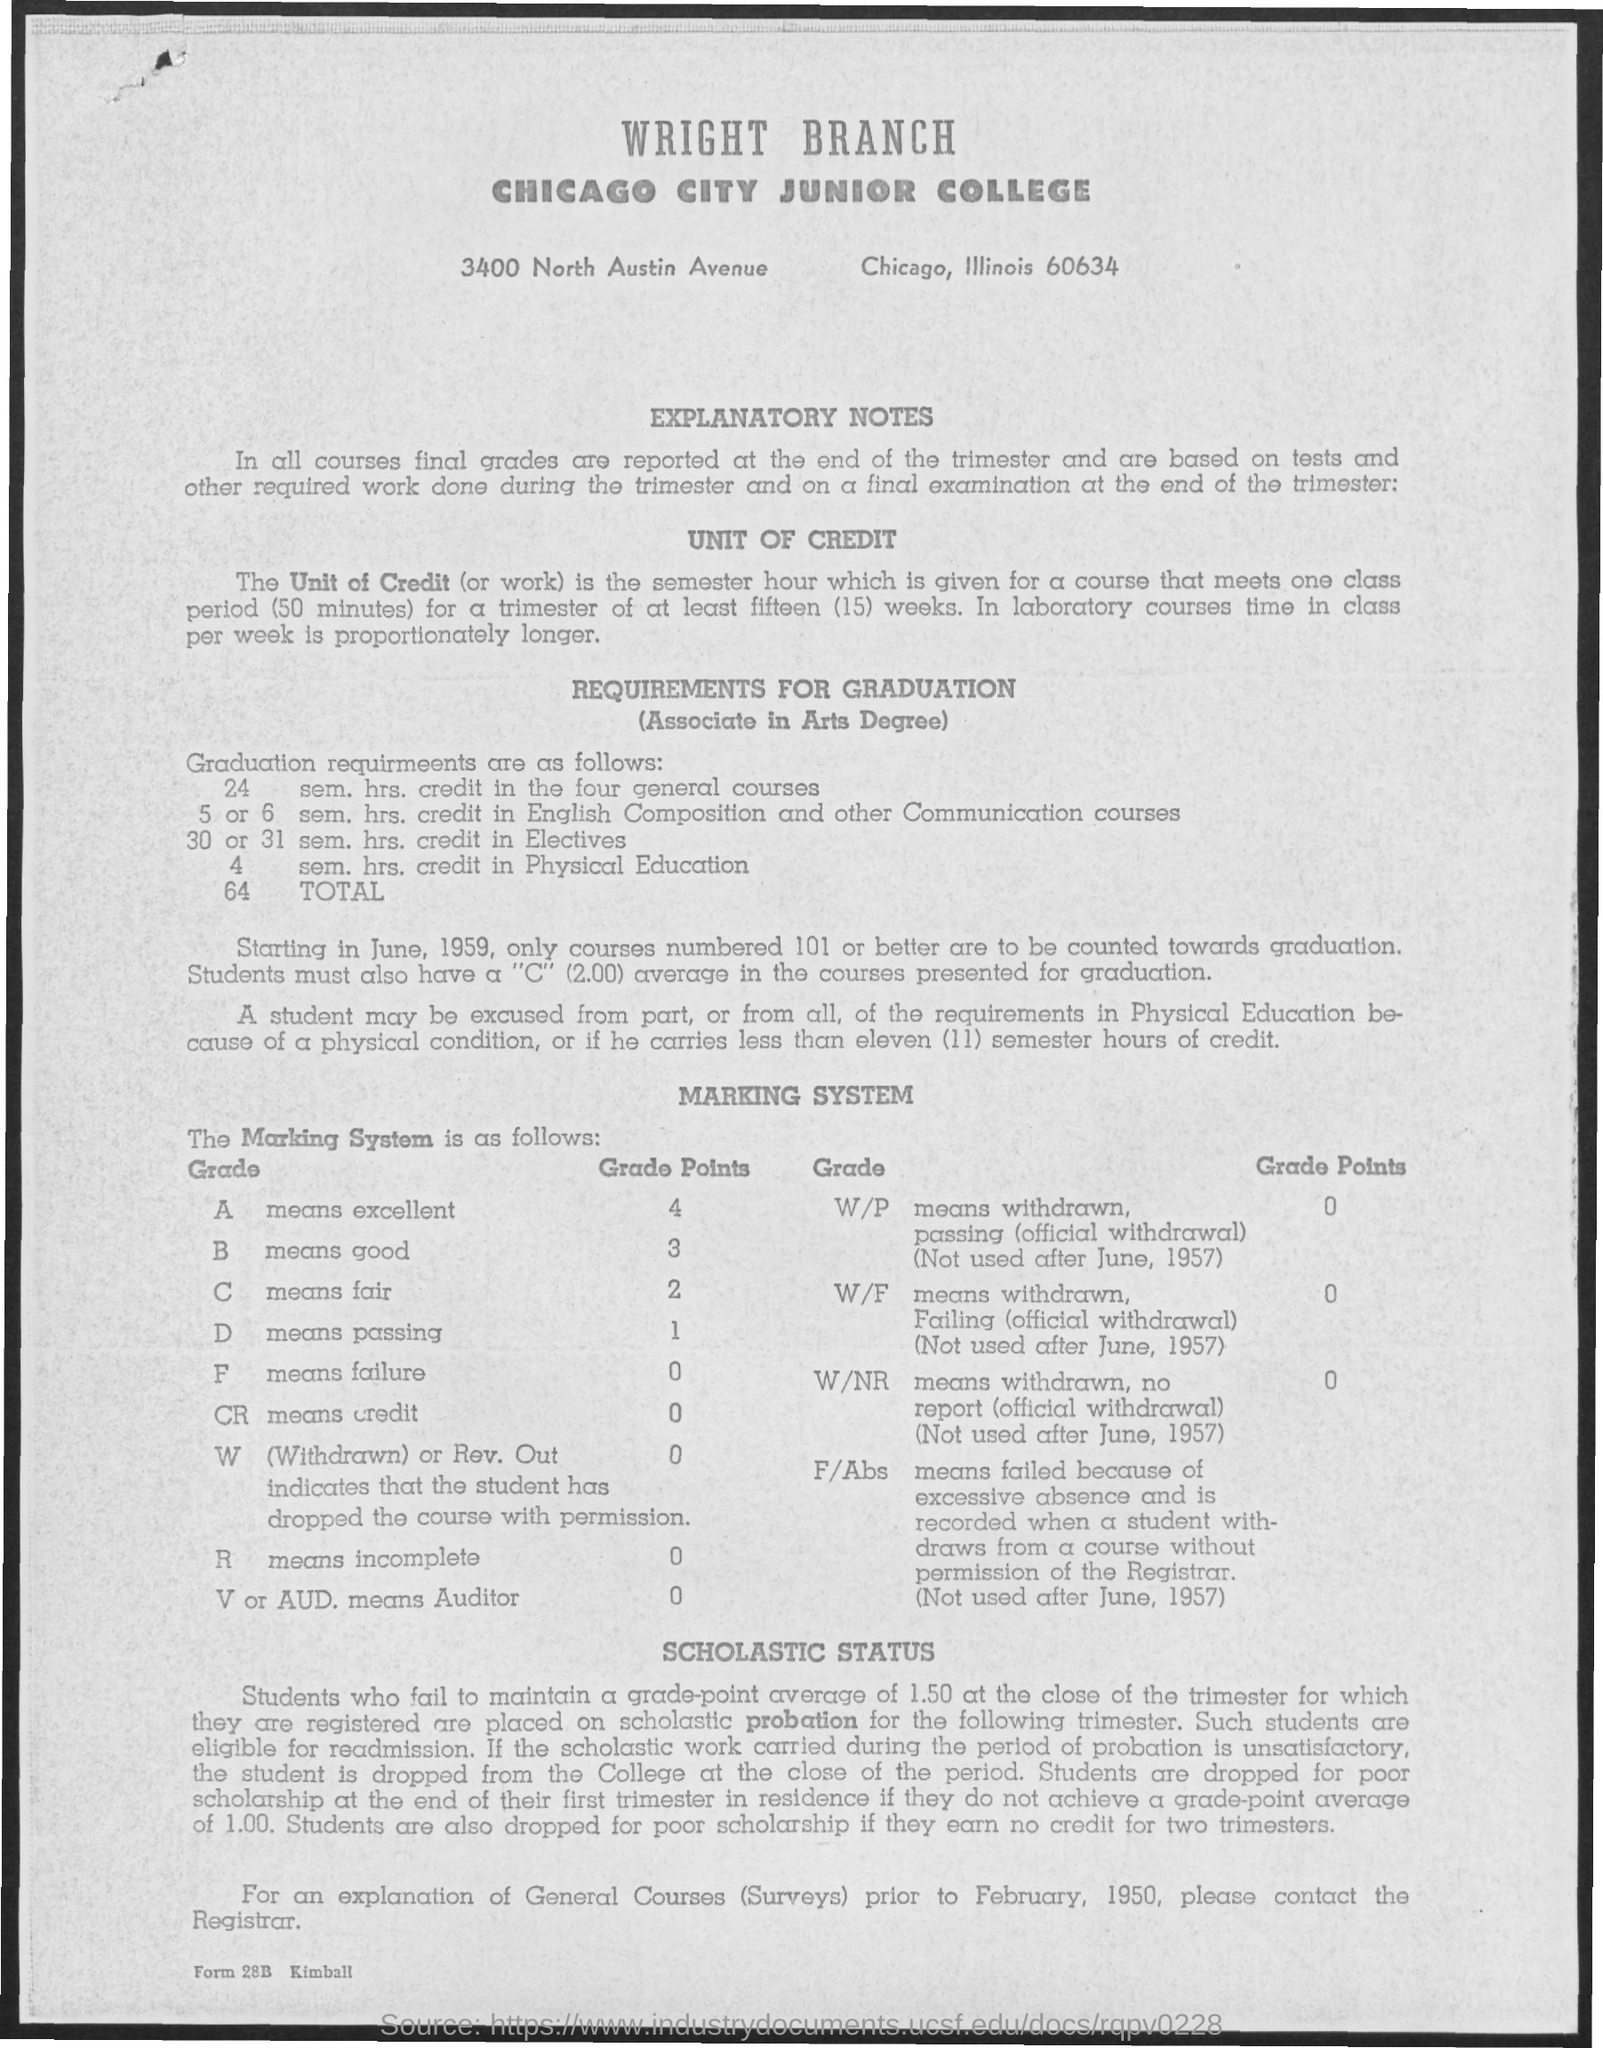What is the first title in the document?
Your answer should be compact. Wright Branch. What is the second title in the document?
Ensure brevity in your answer.  Chicago City Junior College. What is the grade point for "Excellent"?
Your answer should be very brief. 4. What is the grade point for "Failure"?
Provide a succinct answer. 0. What is the grade point for "Fair"?
Keep it short and to the point. 2. What is the grade point for "Good"?
Provide a succinct answer. 3. 